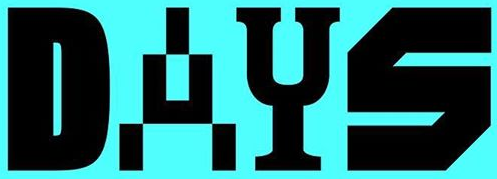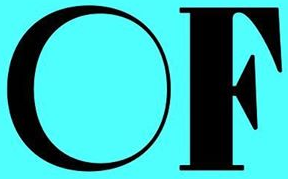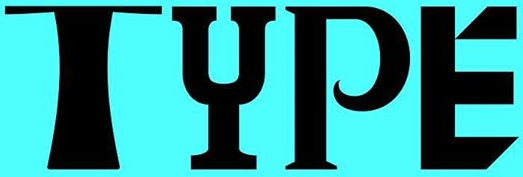What text appears in these images from left to right, separated by a semicolon? DAYS; OF; TYPE 